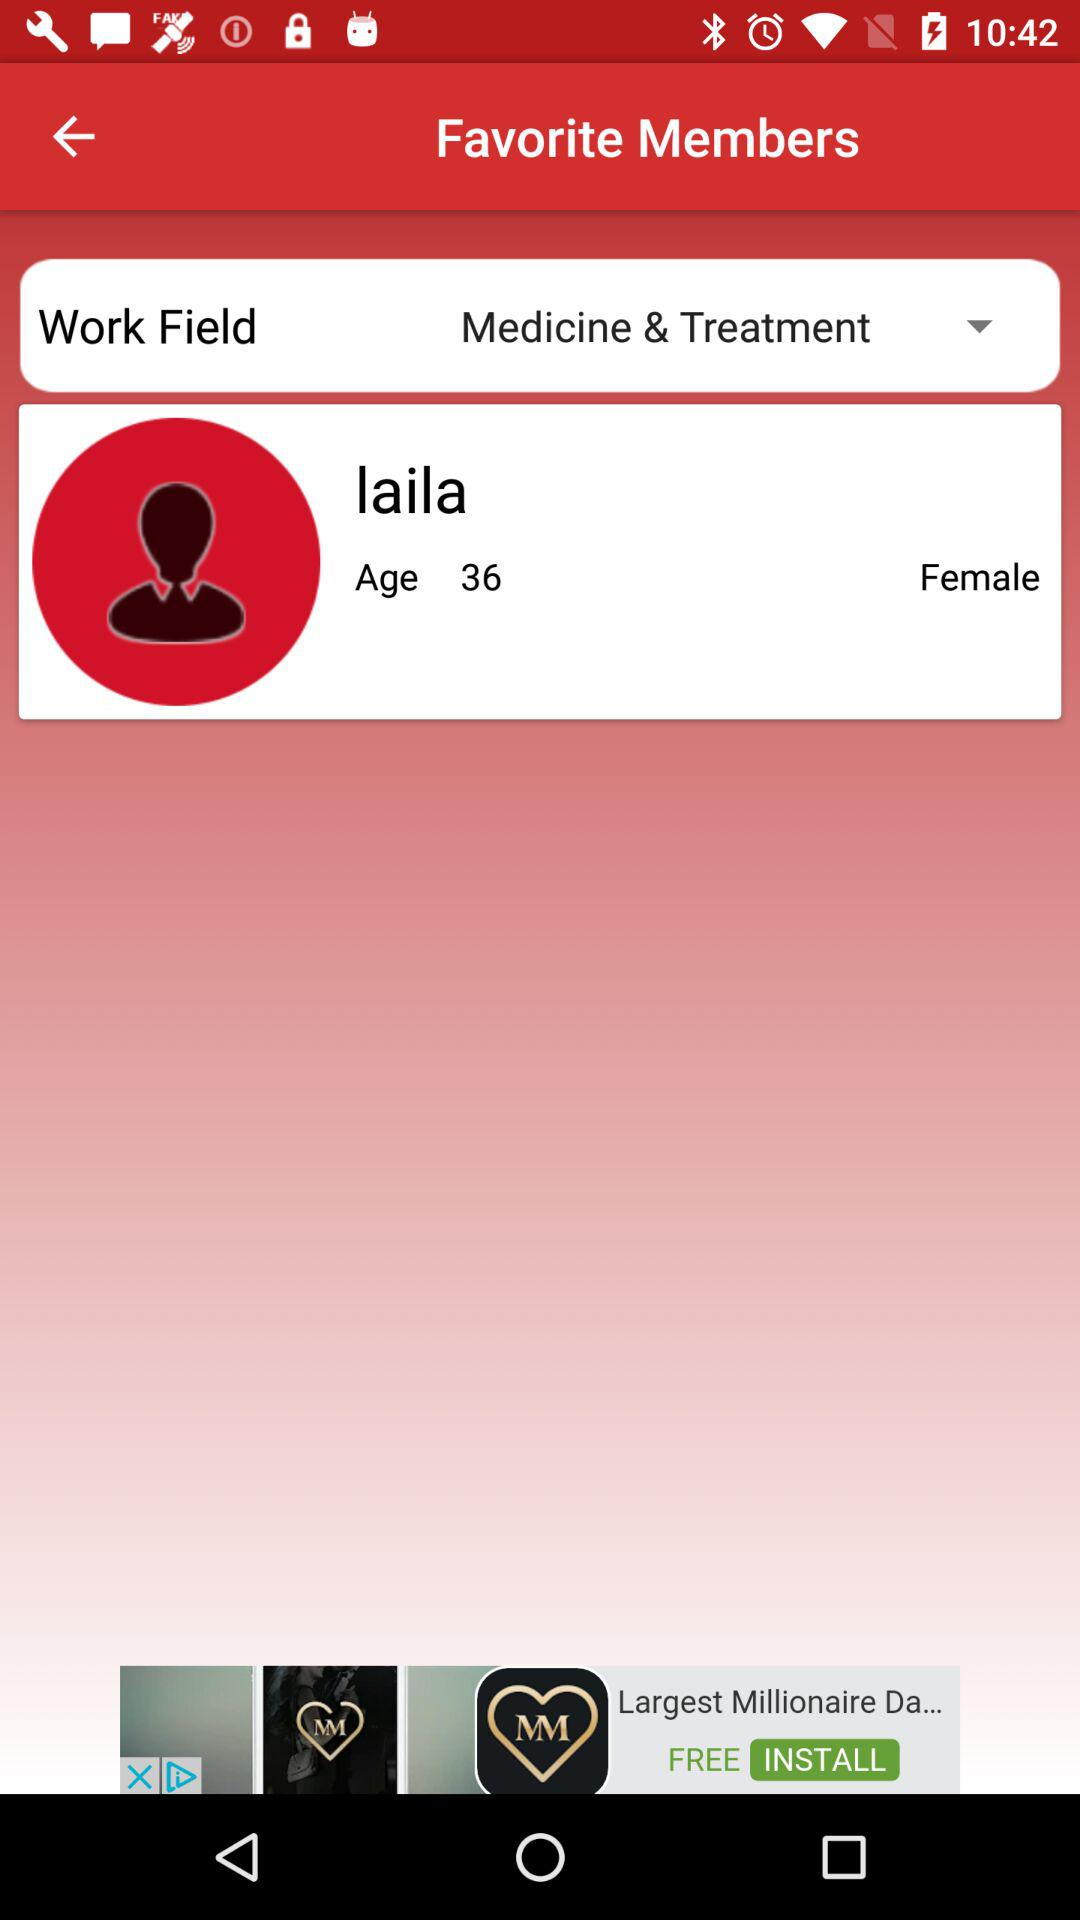What is the gender? The gender is female. 